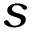<formula> <loc_0><loc_0><loc_500><loc_500>s</formula> 